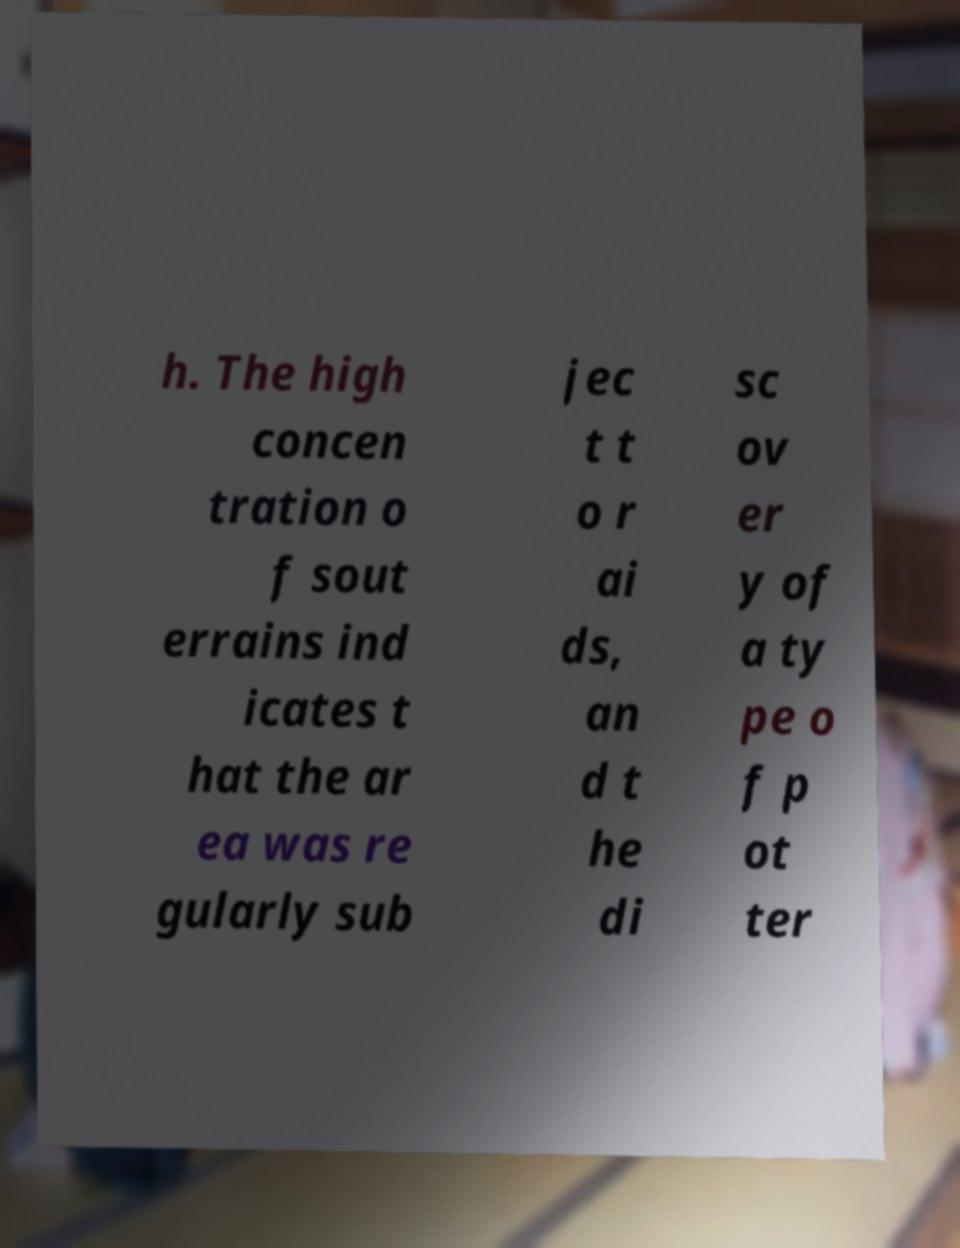There's text embedded in this image that I need extracted. Can you transcribe it verbatim? h. The high concen tration o f sout errains ind icates t hat the ar ea was re gularly sub jec t t o r ai ds, an d t he di sc ov er y of a ty pe o f p ot ter 